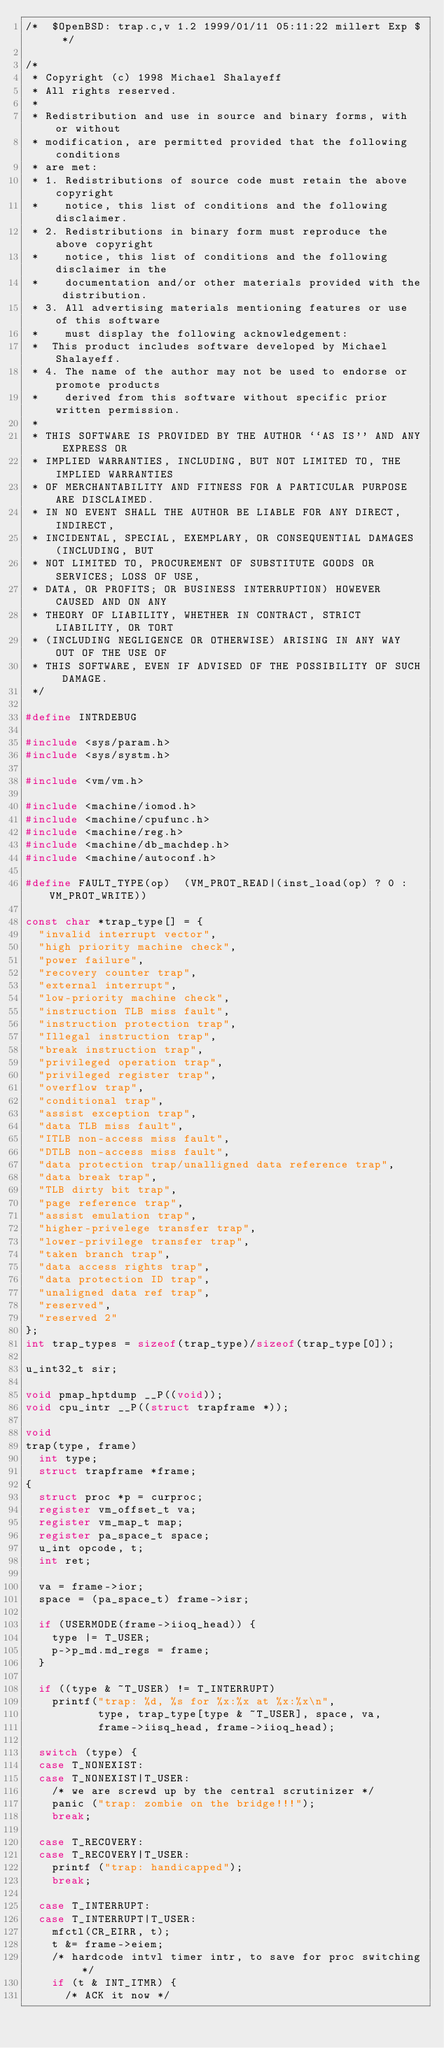<code> <loc_0><loc_0><loc_500><loc_500><_C_>/*	$OpenBSD: trap.c,v 1.2 1999/01/11 05:11:22 millert Exp $	*/

/*
 * Copyright (c) 1998 Michael Shalayeff
 * All rights reserved.
 *
 * Redistribution and use in source and binary forms, with or without
 * modification, are permitted provided that the following conditions
 * are met:
 * 1. Redistributions of source code must retain the above copyright
 *    notice, this list of conditions and the following disclaimer.
 * 2. Redistributions in binary form must reproduce the above copyright
 *    notice, this list of conditions and the following disclaimer in the
 *    documentation and/or other materials provided with the distribution.
 * 3. All advertising materials mentioning features or use of this software
 *    must display the following acknowledgement:
 *	This product includes software developed by Michael Shalayeff.
 * 4. The name of the author may not be used to endorse or promote products
 *    derived from this software without specific prior written permission.
 *
 * THIS SOFTWARE IS PROVIDED BY THE AUTHOR ``AS IS'' AND ANY EXPRESS OR
 * IMPLIED WARRANTIES, INCLUDING, BUT NOT LIMITED TO, THE IMPLIED WARRANTIES
 * OF MERCHANTABILITY AND FITNESS FOR A PARTICULAR PURPOSE ARE DISCLAIMED.
 * IN NO EVENT SHALL THE AUTHOR BE LIABLE FOR ANY DIRECT, INDIRECT,
 * INCIDENTAL, SPECIAL, EXEMPLARY, OR CONSEQUENTIAL DAMAGES (INCLUDING, BUT
 * NOT LIMITED TO, PROCUREMENT OF SUBSTITUTE GOODS OR SERVICES; LOSS OF USE,
 * DATA, OR PROFITS; OR BUSINESS INTERRUPTION) HOWEVER CAUSED AND ON ANY
 * THEORY OF LIABILITY, WHETHER IN CONTRACT, STRICT LIABILITY, OR TORT
 * (INCLUDING NEGLIGENCE OR OTHERWISE) ARISING IN ANY WAY OUT OF THE USE OF
 * THIS SOFTWARE, EVEN IF ADVISED OF THE POSSIBILITY OF SUCH DAMAGE.
 */

#define INTRDEBUG

#include <sys/param.h>
#include <sys/systm.h>

#include <vm/vm.h>

#include <machine/iomod.h>
#include <machine/cpufunc.h>
#include <machine/reg.h>
#include <machine/db_machdep.h>
#include <machine/autoconf.h>

#define	FAULT_TYPE(op)	(VM_PROT_READ|(inst_load(op) ? 0 : VM_PROT_WRITE))

const char *trap_type[] = {
	"invalid interrupt vector",
	"high priority machine check",
	"power failure",
	"recovery counter trap",
	"external interrupt",
	"low-priority machine check",
	"instruction TLB miss fault",
	"instruction protection trap",
	"Illegal instruction trap",
	"break instruction trap",
	"privileged operation trap",
	"privileged register trap",
	"overflow trap",
	"conditional trap",
	"assist exception trap",
	"data TLB miss fault",
	"ITLB non-access miss fault",
	"DTLB non-access miss fault",
	"data protection trap/unalligned data reference trap",
	"data break trap",
	"TLB dirty bit trap",
	"page reference trap",
	"assist emulation trap",
	"higher-privelege transfer trap",
	"lower-privilege transfer trap",
	"taken branch trap",
	"data access rights trap",
	"data protection ID trap",
	"unaligned data ref trap",
	"reserved",
	"reserved 2"
};
int trap_types = sizeof(trap_type)/sizeof(trap_type[0]);

u_int32_t sir;

void pmap_hptdump __P((void));
void cpu_intr __P((struct trapframe *));

void
trap(type, frame)
	int type;
	struct trapframe *frame;
{
	struct proc *p = curproc;
	register vm_offset_t va;
	register vm_map_t map;
	register pa_space_t space;
	u_int opcode, t;
	int ret;

	va = frame->ior;
	space = (pa_space_t) frame->isr;

	if (USERMODE(frame->iioq_head)) {
		type |= T_USER;
		p->p_md.md_regs = frame;
	}

	if ((type & ~T_USER) != T_INTERRUPT)
		printf("trap: %d, %s for %x:%x at %x:%x\n",
		       type, trap_type[type & ~T_USER], space, va,
		       frame->iisq_head, frame->iioq_head);

	switch (type) {
	case T_NONEXIST:
	case T_NONEXIST|T_USER:
		/* we are screwd up by the central scrutinizer */
		panic ("trap: zombie on the bridge!!!");
		break;

	case T_RECOVERY:
	case T_RECOVERY|T_USER:
		printf ("trap: handicapped");
		break;

	case T_INTERRUPT:
	case T_INTERRUPT|T_USER:
		mfctl(CR_EIRR, t);
		t &= frame->eiem;
		/* hardcode intvl timer intr, to save for proc switching */
		if (t & INT_ITMR) {
			/* ACK it now */</code> 